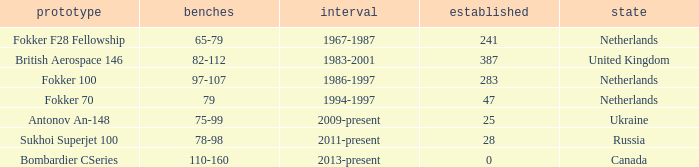How many cabins were built in the time between 1967-1987? 241.0. 